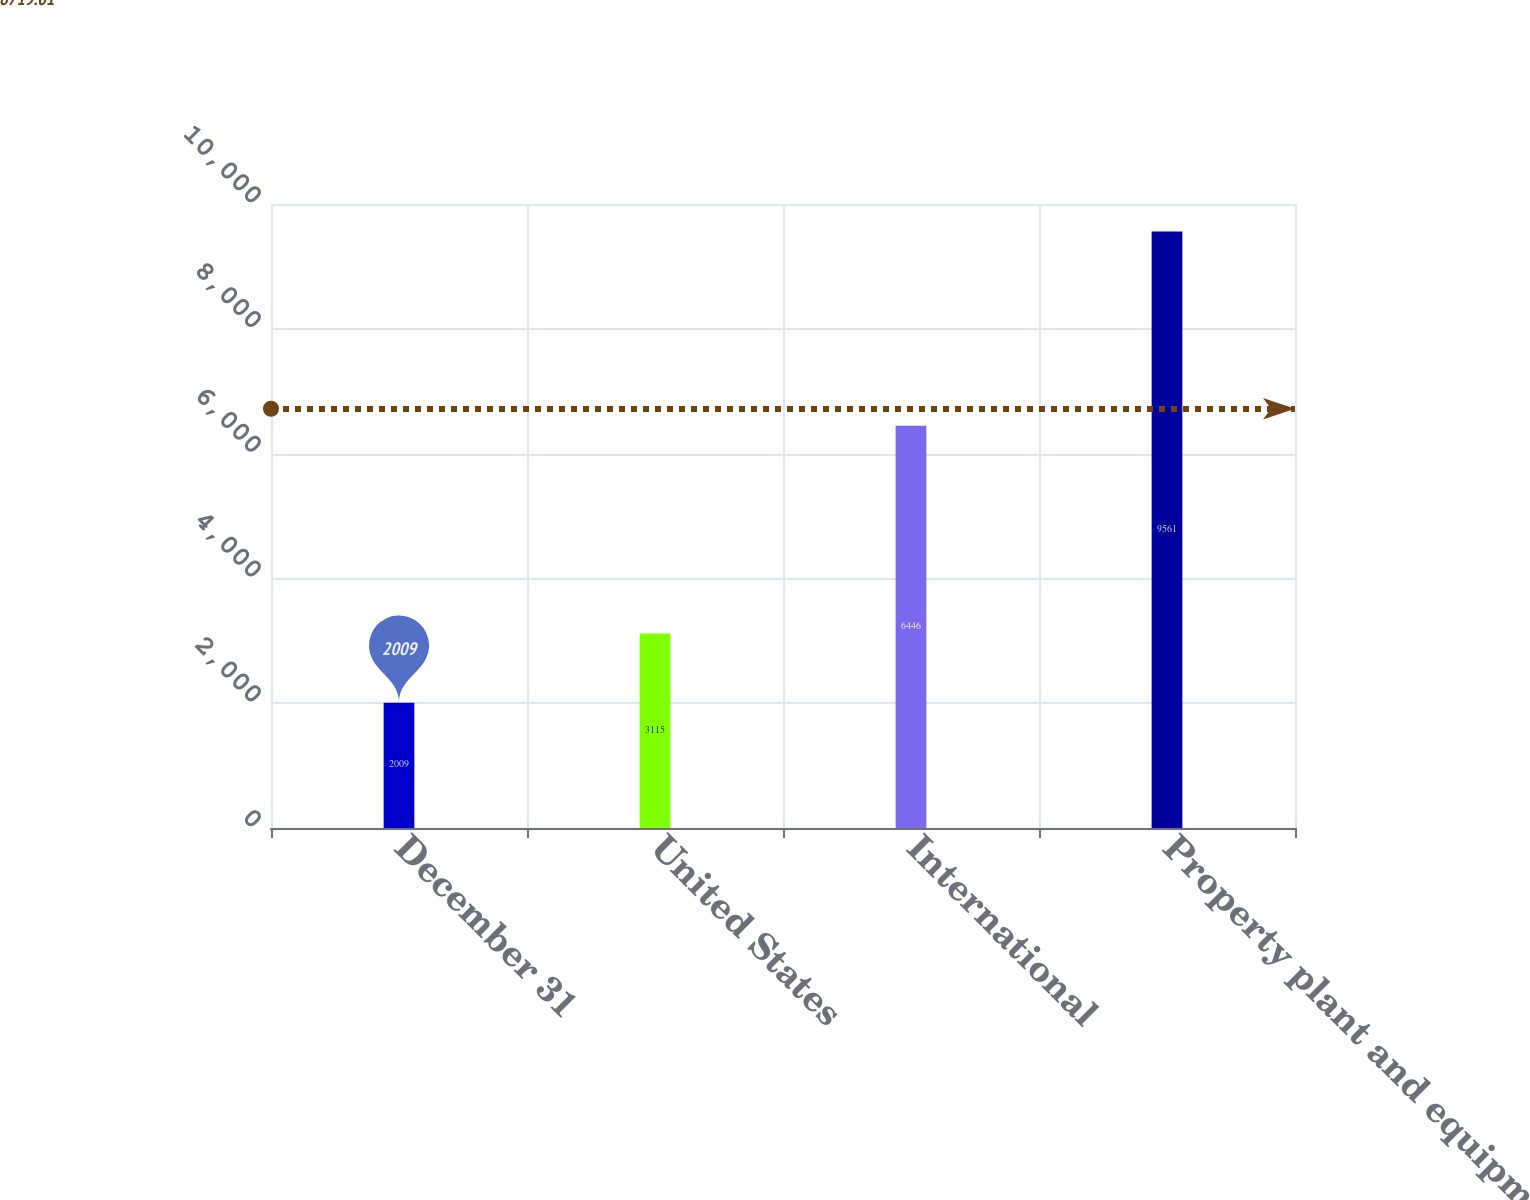Convert chart to OTSL. <chart><loc_0><loc_0><loc_500><loc_500><bar_chart><fcel>December 31<fcel>United States<fcel>International<fcel>Property plant and equipment -<nl><fcel>2009<fcel>3115<fcel>6446<fcel>9561<nl></chart> 